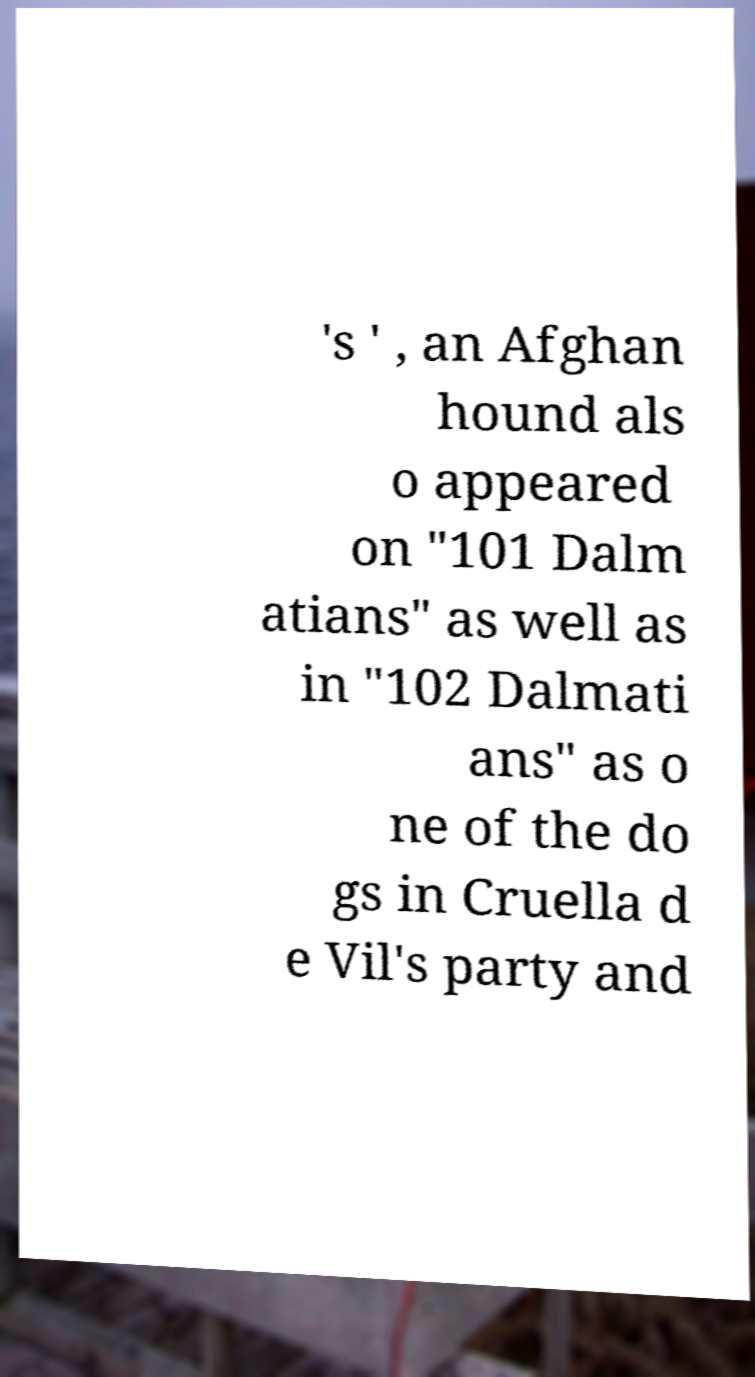For documentation purposes, I need the text within this image transcribed. Could you provide that? 's ' , an Afghan hound als o appeared on "101 Dalm atians" as well as in "102 Dalmati ans" as o ne of the do gs in Cruella d e Vil's party and 